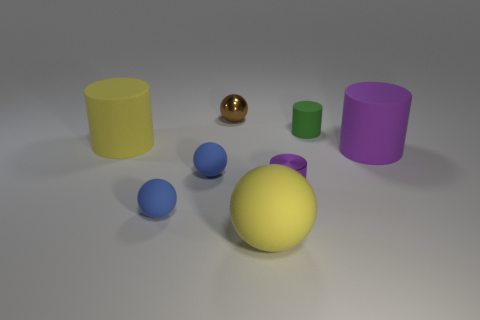The big rubber thing left of the large yellow sphere has what shape?
Your response must be concise. Cylinder. How many yellow things are small spheres or tiny matte cylinders?
Offer a terse response. 0. Does the tiny brown sphere have the same material as the green object?
Your answer should be very brief. No. There is a tiny purple cylinder; what number of brown objects are in front of it?
Your response must be concise. 0. What material is the thing that is left of the big purple cylinder and right of the tiny purple cylinder?
Keep it short and to the point. Rubber. How many cylinders are either green objects or yellow rubber objects?
Offer a very short reply. 2. There is a small purple object that is the same shape as the green rubber thing; what is its material?
Give a very brief answer. Metal. The green cylinder that is made of the same material as the big yellow ball is what size?
Ensure brevity in your answer.  Small. There is a yellow thing left of the brown metallic ball; is it the same shape as the tiny purple metallic thing that is left of the big purple object?
Your answer should be compact. Yes. What is the color of the other large cylinder that is made of the same material as the large yellow cylinder?
Your answer should be very brief. Purple. 